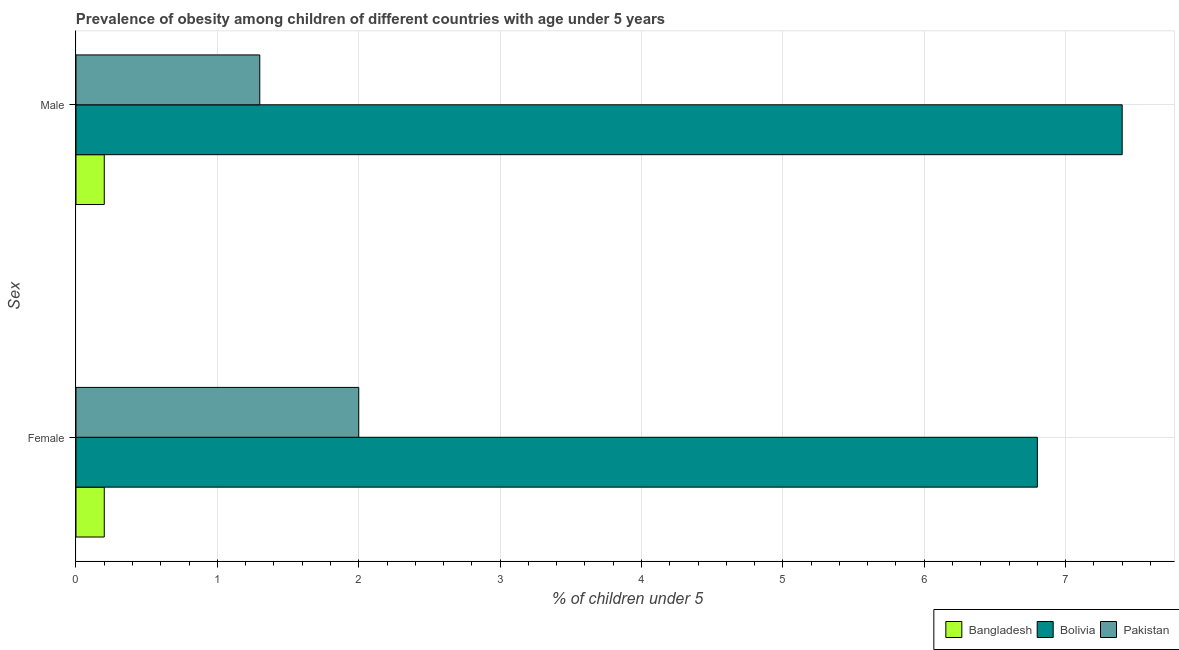How many groups of bars are there?
Offer a very short reply. 2. Are the number of bars on each tick of the Y-axis equal?
Offer a terse response. Yes. How many bars are there on the 2nd tick from the top?
Your answer should be compact. 3. How many bars are there on the 2nd tick from the bottom?
Offer a terse response. 3. What is the label of the 1st group of bars from the top?
Your answer should be very brief. Male. What is the percentage of obese male children in Bangladesh?
Ensure brevity in your answer.  0.2. Across all countries, what is the maximum percentage of obese female children?
Your answer should be very brief. 6.8. Across all countries, what is the minimum percentage of obese female children?
Keep it short and to the point. 0.2. In which country was the percentage of obese male children maximum?
Offer a very short reply. Bolivia. In which country was the percentage of obese male children minimum?
Your answer should be very brief. Bangladesh. What is the total percentage of obese female children in the graph?
Provide a short and direct response. 9. What is the difference between the percentage of obese male children in Bolivia and that in Pakistan?
Offer a very short reply. 6.1. What is the difference between the percentage of obese female children in Bolivia and the percentage of obese male children in Bangladesh?
Keep it short and to the point. 6.6. What is the average percentage of obese female children per country?
Your response must be concise. 3. What is the difference between the percentage of obese female children and percentage of obese male children in Bolivia?
Provide a short and direct response. -0.6. What is the ratio of the percentage of obese female children in Pakistan to that in Bolivia?
Offer a terse response. 0.29. Is the percentage of obese female children in Bangladesh less than that in Bolivia?
Provide a short and direct response. Yes. How many bars are there?
Provide a short and direct response. 6. How many countries are there in the graph?
Provide a short and direct response. 3. Are the values on the major ticks of X-axis written in scientific E-notation?
Keep it short and to the point. No. Does the graph contain any zero values?
Your answer should be compact. No. Where does the legend appear in the graph?
Your answer should be very brief. Bottom right. How many legend labels are there?
Make the answer very short. 3. How are the legend labels stacked?
Your answer should be very brief. Horizontal. What is the title of the graph?
Offer a very short reply. Prevalence of obesity among children of different countries with age under 5 years. Does "Algeria" appear as one of the legend labels in the graph?
Your answer should be compact. No. What is the label or title of the X-axis?
Your answer should be compact.  % of children under 5. What is the label or title of the Y-axis?
Provide a short and direct response. Sex. What is the  % of children under 5 in Bangladesh in Female?
Your response must be concise. 0.2. What is the  % of children under 5 in Bolivia in Female?
Provide a succinct answer. 6.8. What is the  % of children under 5 in Pakistan in Female?
Your response must be concise. 2. What is the  % of children under 5 of Bangladesh in Male?
Give a very brief answer. 0.2. What is the  % of children under 5 of Bolivia in Male?
Offer a terse response. 7.4. What is the  % of children under 5 of Pakistan in Male?
Your answer should be very brief. 1.3. Across all Sex, what is the maximum  % of children under 5 of Bangladesh?
Provide a succinct answer. 0.2. Across all Sex, what is the maximum  % of children under 5 in Bolivia?
Make the answer very short. 7.4. Across all Sex, what is the maximum  % of children under 5 in Pakistan?
Keep it short and to the point. 2. Across all Sex, what is the minimum  % of children under 5 of Bangladesh?
Your answer should be very brief. 0.2. Across all Sex, what is the minimum  % of children under 5 in Bolivia?
Offer a very short reply. 6.8. Across all Sex, what is the minimum  % of children under 5 in Pakistan?
Your response must be concise. 1.3. What is the total  % of children under 5 of Bolivia in the graph?
Ensure brevity in your answer.  14.2. What is the difference between the  % of children under 5 in Pakistan in Female and that in Male?
Make the answer very short. 0.7. What is the difference between the  % of children under 5 of Bangladesh in Female and the  % of children under 5 of Bolivia in Male?
Keep it short and to the point. -7.2. What is the difference between the  % of children under 5 in Bangladesh in Female and the  % of children under 5 in Pakistan in Male?
Provide a succinct answer. -1.1. What is the average  % of children under 5 in Pakistan per Sex?
Provide a succinct answer. 1.65. What is the difference between the  % of children under 5 in Bangladesh and  % of children under 5 in Bolivia in Male?
Offer a very short reply. -7.2. What is the difference between the  % of children under 5 in Bangladesh and  % of children under 5 in Pakistan in Male?
Keep it short and to the point. -1.1. What is the difference between the  % of children under 5 in Bolivia and  % of children under 5 in Pakistan in Male?
Offer a very short reply. 6.1. What is the ratio of the  % of children under 5 in Bolivia in Female to that in Male?
Offer a terse response. 0.92. What is the ratio of the  % of children under 5 of Pakistan in Female to that in Male?
Your response must be concise. 1.54. What is the difference between the highest and the second highest  % of children under 5 in Bangladesh?
Make the answer very short. 0. What is the difference between the highest and the second highest  % of children under 5 of Pakistan?
Offer a very short reply. 0.7. What is the difference between the highest and the lowest  % of children under 5 of Bolivia?
Provide a short and direct response. 0.6. 